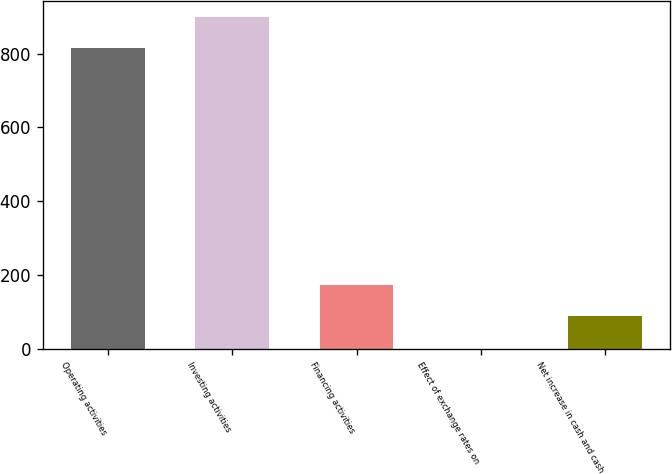Convert chart. <chart><loc_0><loc_0><loc_500><loc_500><bar_chart><fcel>Operating activities<fcel>Investing activities<fcel>Financing activities<fcel>Effect of exchange rates on<fcel>Net increase in cash and cash<nl><fcel>814.2<fcel>898.75<fcel>172.45<fcel>0.2<fcel>87.9<nl></chart> 